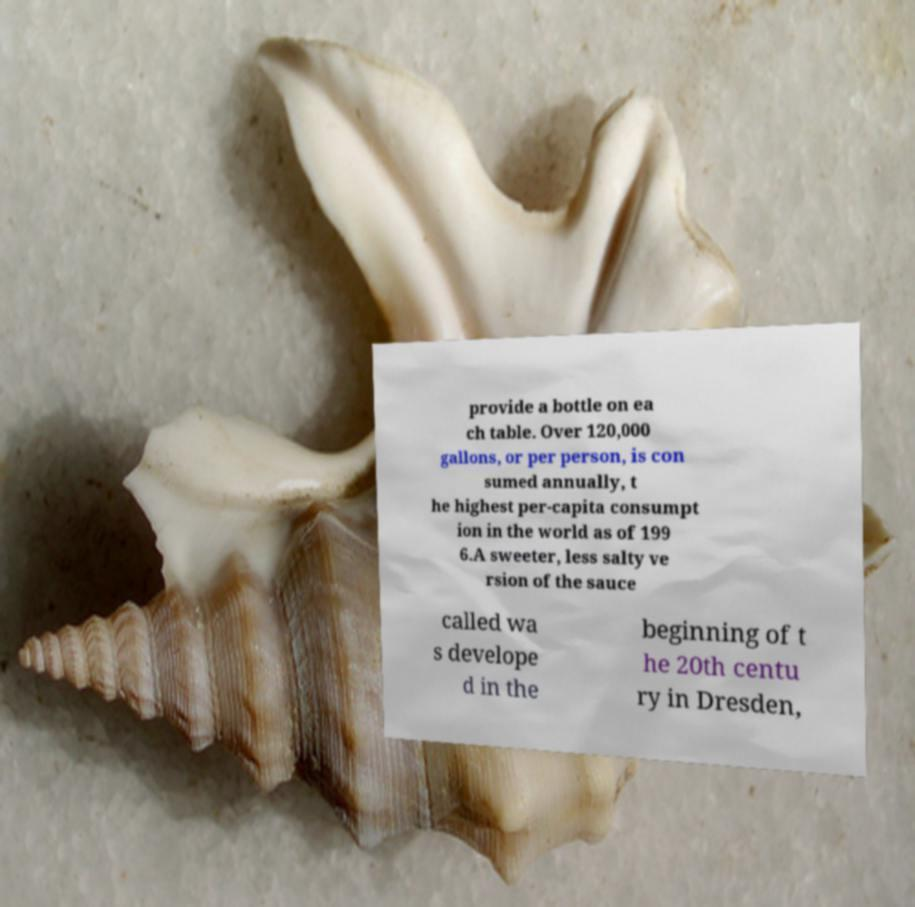There's text embedded in this image that I need extracted. Can you transcribe it verbatim? provide a bottle on ea ch table. Over 120,000 gallons, or per person, is con sumed annually, t he highest per-capita consumpt ion in the world as of 199 6.A sweeter, less salty ve rsion of the sauce called wa s develope d in the beginning of t he 20th centu ry in Dresden, 